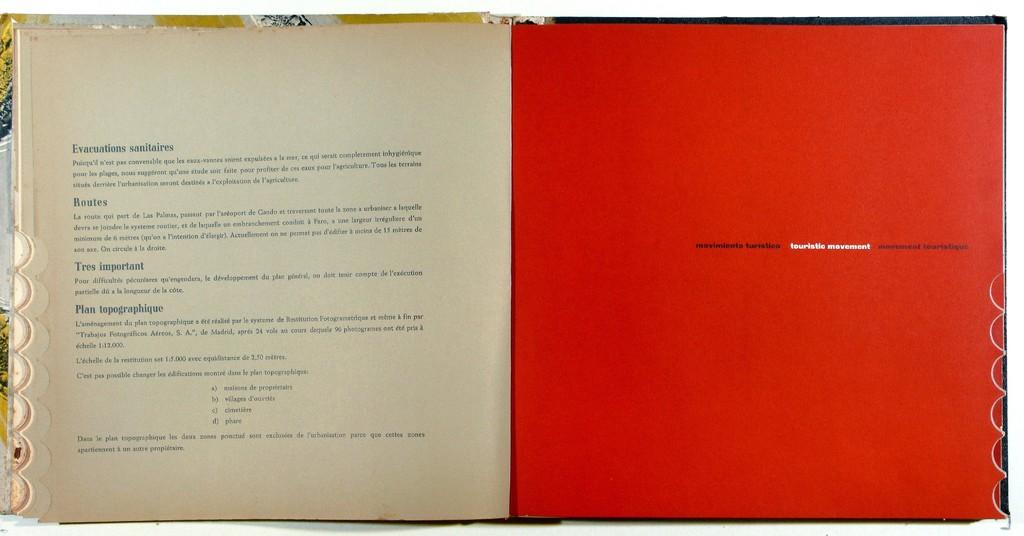<image>
Give a short and clear explanation of the subsequent image. An open French book discussing routes and evacuations. 